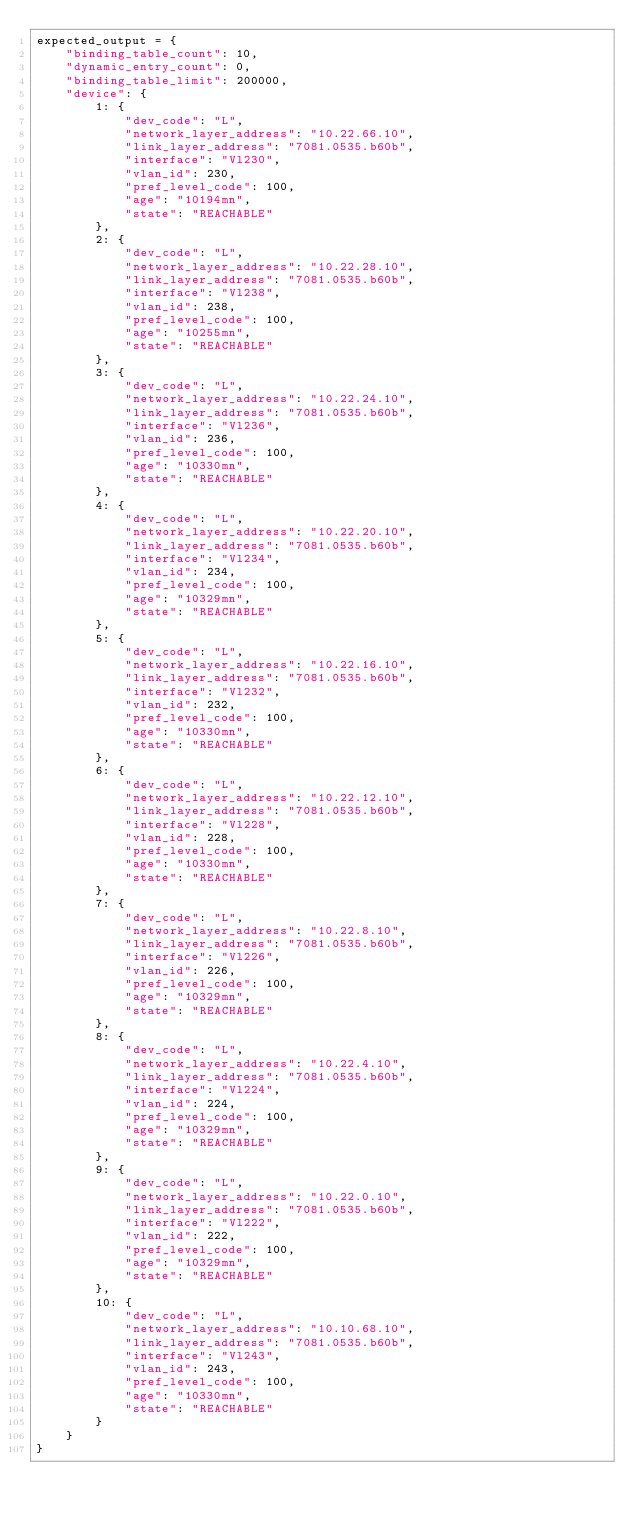Convert code to text. <code><loc_0><loc_0><loc_500><loc_500><_Python_>expected_output = {
    "binding_table_count": 10,
    "dynamic_entry_count": 0,
    "binding_table_limit": 200000,
    "device": {
        1: {
            "dev_code": "L",
            "network_layer_address": "10.22.66.10",
            "link_layer_address": "7081.0535.b60b",
            "interface": "Vl230",
            "vlan_id": 230,
            "pref_level_code": 100,
            "age": "10194mn",
            "state": "REACHABLE"
        },
        2: {
            "dev_code": "L",
            "network_layer_address": "10.22.28.10",
            "link_layer_address": "7081.0535.b60b",
            "interface": "Vl238",
            "vlan_id": 238,
            "pref_level_code": 100,
            "age": "10255mn",
            "state": "REACHABLE"
        },
        3: {
            "dev_code": "L",
            "network_layer_address": "10.22.24.10",
            "link_layer_address": "7081.0535.b60b",
            "interface": "Vl236",
            "vlan_id": 236,
            "pref_level_code": 100,
            "age": "10330mn",
            "state": "REACHABLE"
        },
        4: {
            "dev_code": "L",
            "network_layer_address": "10.22.20.10",
            "link_layer_address": "7081.0535.b60b",
            "interface": "Vl234",
            "vlan_id": 234,
            "pref_level_code": 100,
            "age": "10329mn",
            "state": "REACHABLE"
        },
        5: {
            "dev_code": "L",
            "network_layer_address": "10.22.16.10",
            "link_layer_address": "7081.0535.b60b",
            "interface": "Vl232",
            "vlan_id": 232,
            "pref_level_code": 100,
            "age": "10330mn",
            "state": "REACHABLE"
        },
        6: {
            "dev_code": "L",
            "network_layer_address": "10.22.12.10",
            "link_layer_address": "7081.0535.b60b",
            "interface": "Vl228",
            "vlan_id": 228,
            "pref_level_code": 100,
            "age": "10330mn",
            "state": "REACHABLE"
        },
        7: {
            "dev_code": "L",
            "network_layer_address": "10.22.8.10",
            "link_layer_address": "7081.0535.b60b",
            "interface": "Vl226",
            "vlan_id": 226,
            "pref_level_code": 100,
            "age": "10329mn",
            "state": "REACHABLE"
        },
        8: {
            "dev_code": "L",
            "network_layer_address": "10.22.4.10",
            "link_layer_address": "7081.0535.b60b",
            "interface": "Vl224",
            "vlan_id": 224,
            "pref_level_code": 100,
            "age": "10329mn",
            "state": "REACHABLE"
        },
        9: {
            "dev_code": "L",
            "network_layer_address": "10.22.0.10",
            "link_layer_address": "7081.0535.b60b",
            "interface": "Vl222",
            "vlan_id": 222,
            "pref_level_code": 100,
            "age": "10329mn",
            "state": "REACHABLE"
        },
        10: {
            "dev_code": "L",
            "network_layer_address": "10.10.68.10",
            "link_layer_address": "7081.0535.b60b",
            "interface": "Vl243",
            "vlan_id": 243,
            "pref_level_code": 100,
            "age": "10330mn",
            "state": "REACHABLE"
        }
    }
}
</code> 